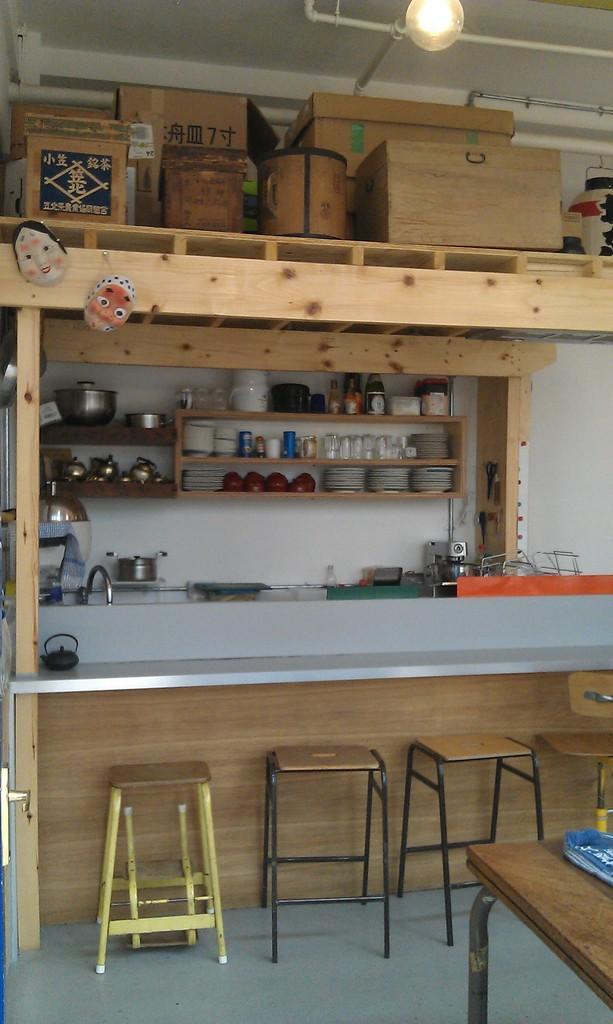Could you give a brief overview of what you see in this image? In this picture there is a table in the right corner and there are few stools in front of it and there is a table above it and there is a wooden object where few kitchen utensils placed in it and there are few wooden boxes and some other objects placed above it. 